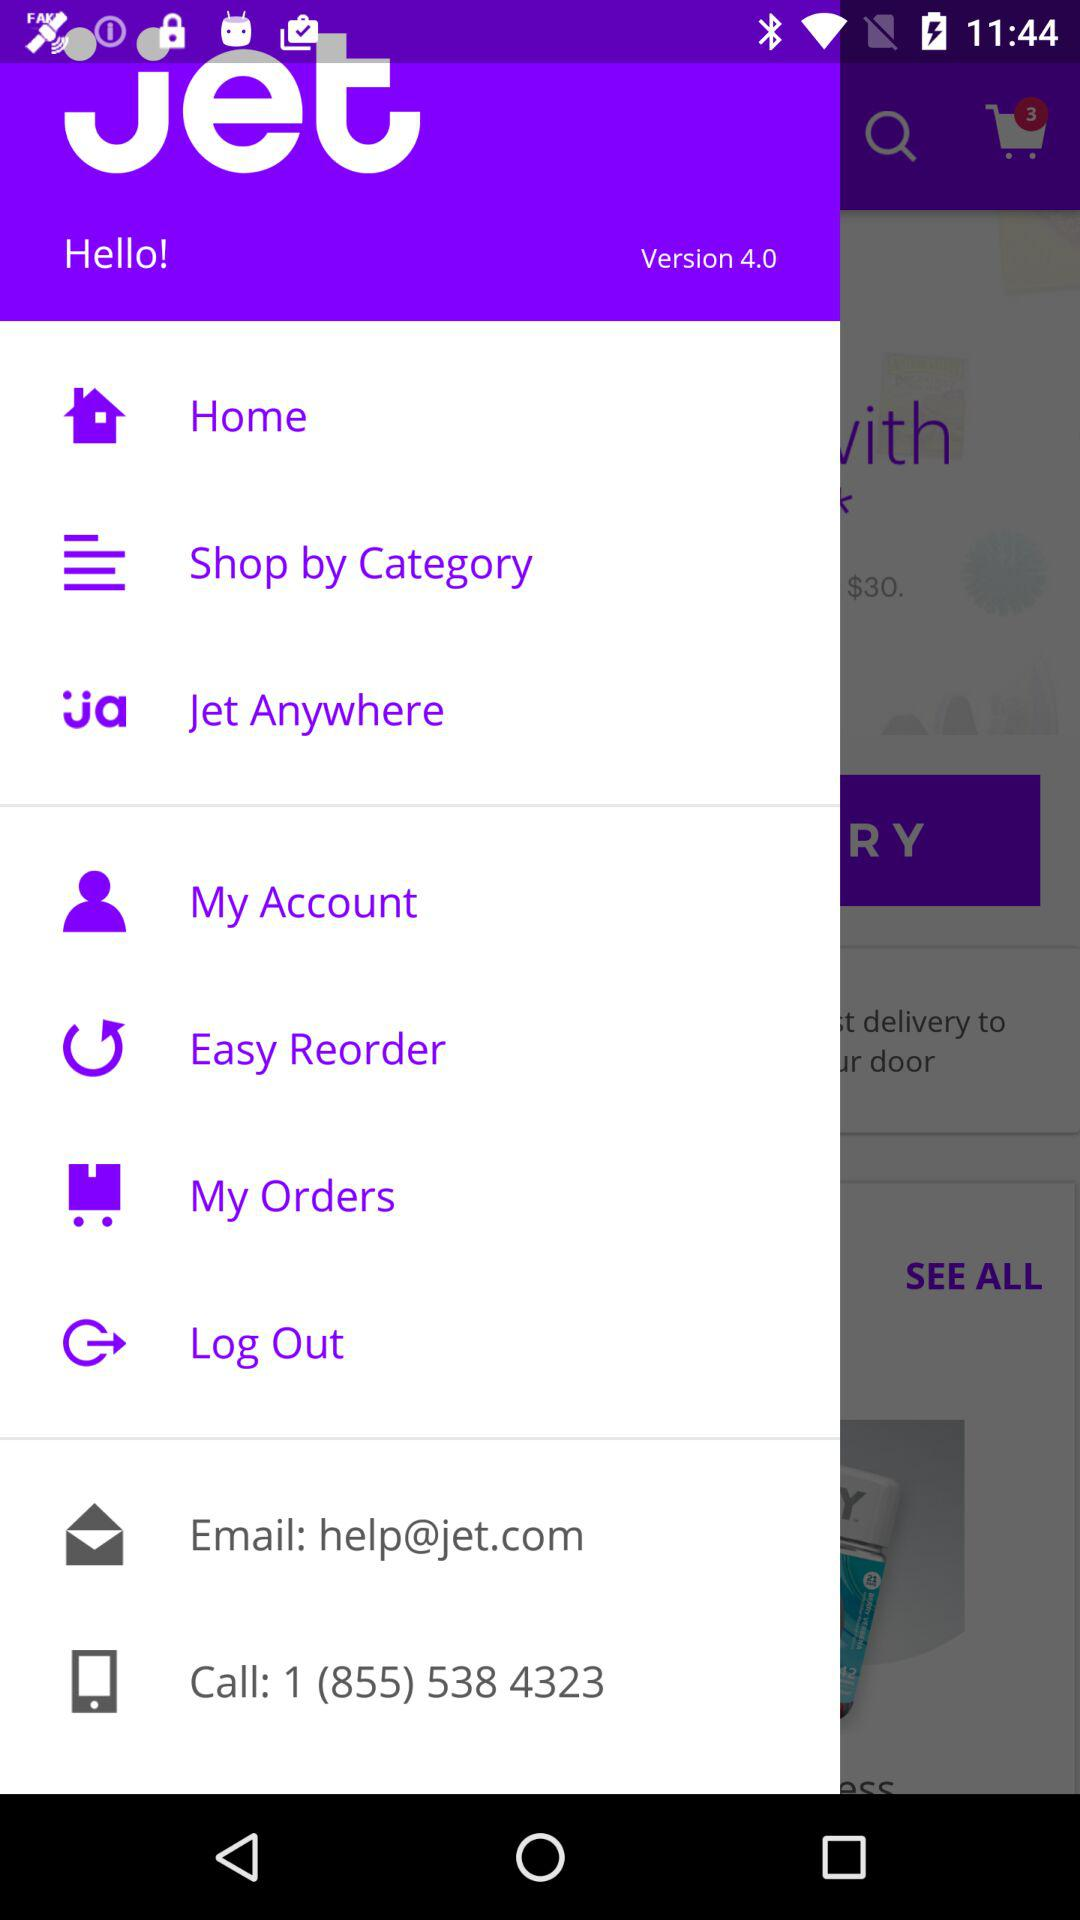What is the version? The version is 4.0. 